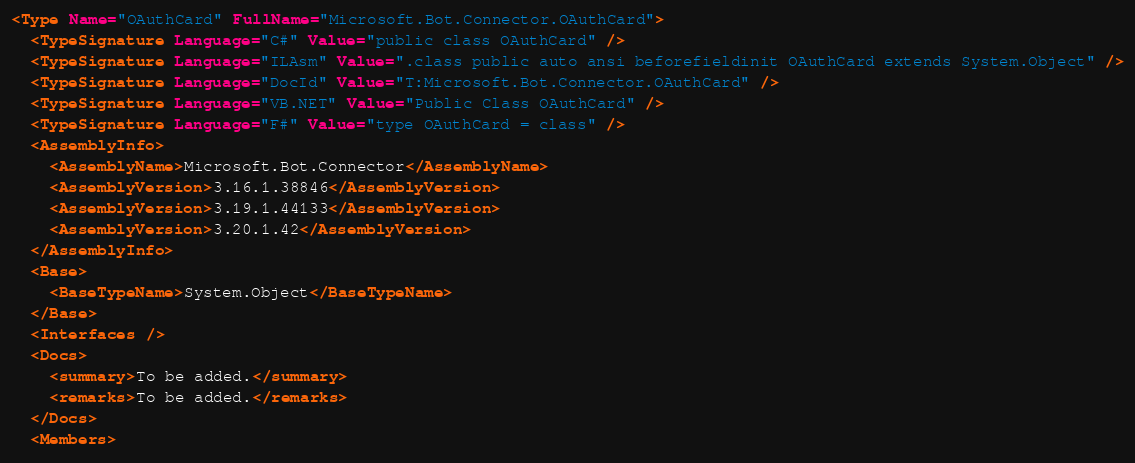<code> <loc_0><loc_0><loc_500><loc_500><_XML_><Type Name="OAuthCard" FullName="Microsoft.Bot.Connector.OAuthCard">
  <TypeSignature Language="C#" Value="public class OAuthCard" />
  <TypeSignature Language="ILAsm" Value=".class public auto ansi beforefieldinit OAuthCard extends System.Object" />
  <TypeSignature Language="DocId" Value="T:Microsoft.Bot.Connector.OAuthCard" />
  <TypeSignature Language="VB.NET" Value="Public Class OAuthCard" />
  <TypeSignature Language="F#" Value="type OAuthCard = class" />
  <AssemblyInfo>
    <AssemblyName>Microsoft.Bot.Connector</AssemblyName>
    <AssemblyVersion>3.16.1.38846</AssemblyVersion>
    <AssemblyVersion>3.19.1.44133</AssemblyVersion>
    <AssemblyVersion>3.20.1.42</AssemblyVersion>
  </AssemblyInfo>
  <Base>
    <BaseTypeName>System.Object</BaseTypeName>
  </Base>
  <Interfaces />
  <Docs>
    <summary>To be added.</summary>
    <remarks>To be added.</remarks>
  </Docs>
  <Members></code> 